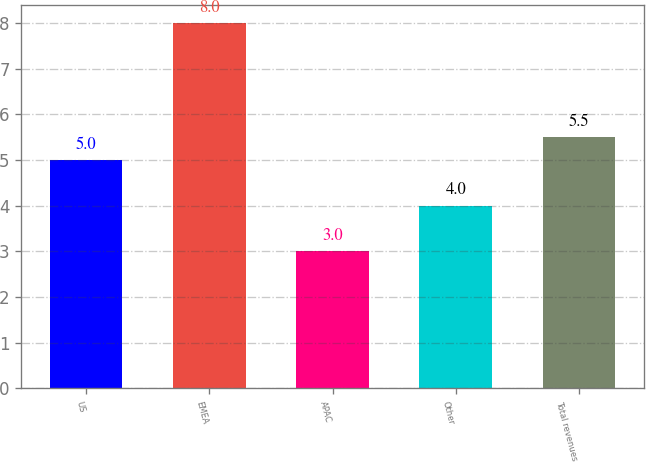<chart> <loc_0><loc_0><loc_500><loc_500><bar_chart><fcel>US<fcel>EMEA<fcel>APAC<fcel>Other<fcel>Total revenues<nl><fcel>5<fcel>8<fcel>3<fcel>4<fcel>5.5<nl></chart> 